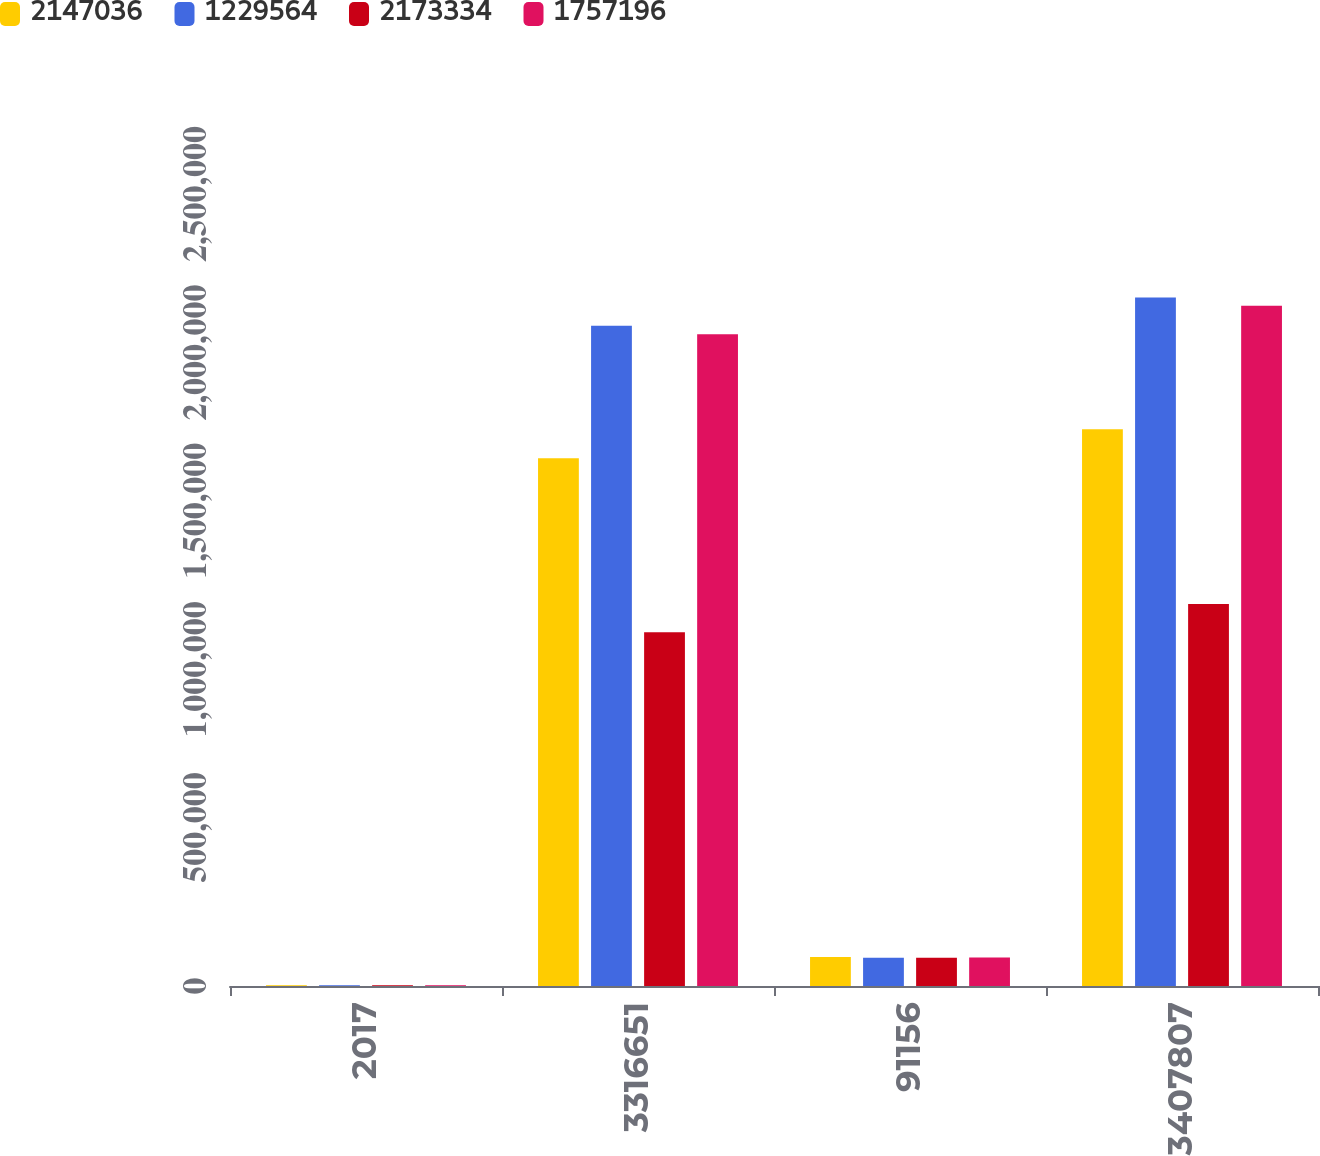Convert chart to OTSL. <chart><loc_0><loc_0><loc_500><loc_500><stacked_bar_chart><ecel><fcel>2017<fcel>3316651<fcel>91156<fcel>3407807<nl><fcel>2.14704e+06<fcel>2017<fcel>1.66604e+06<fcel>91156<fcel>1.7572e+06<nl><fcel>1.22956e+06<fcel>2016<fcel>2.08421e+06<fcel>89124<fcel>2.17333e+06<nl><fcel>2.17333e+06<fcel>2016<fcel>1.11634e+06<fcel>89124<fcel>1.20546e+06<nl><fcel>1.7572e+06<fcel>2015<fcel>2.05744e+06<fcel>89593<fcel>2.14704e+06<nl></chart> 